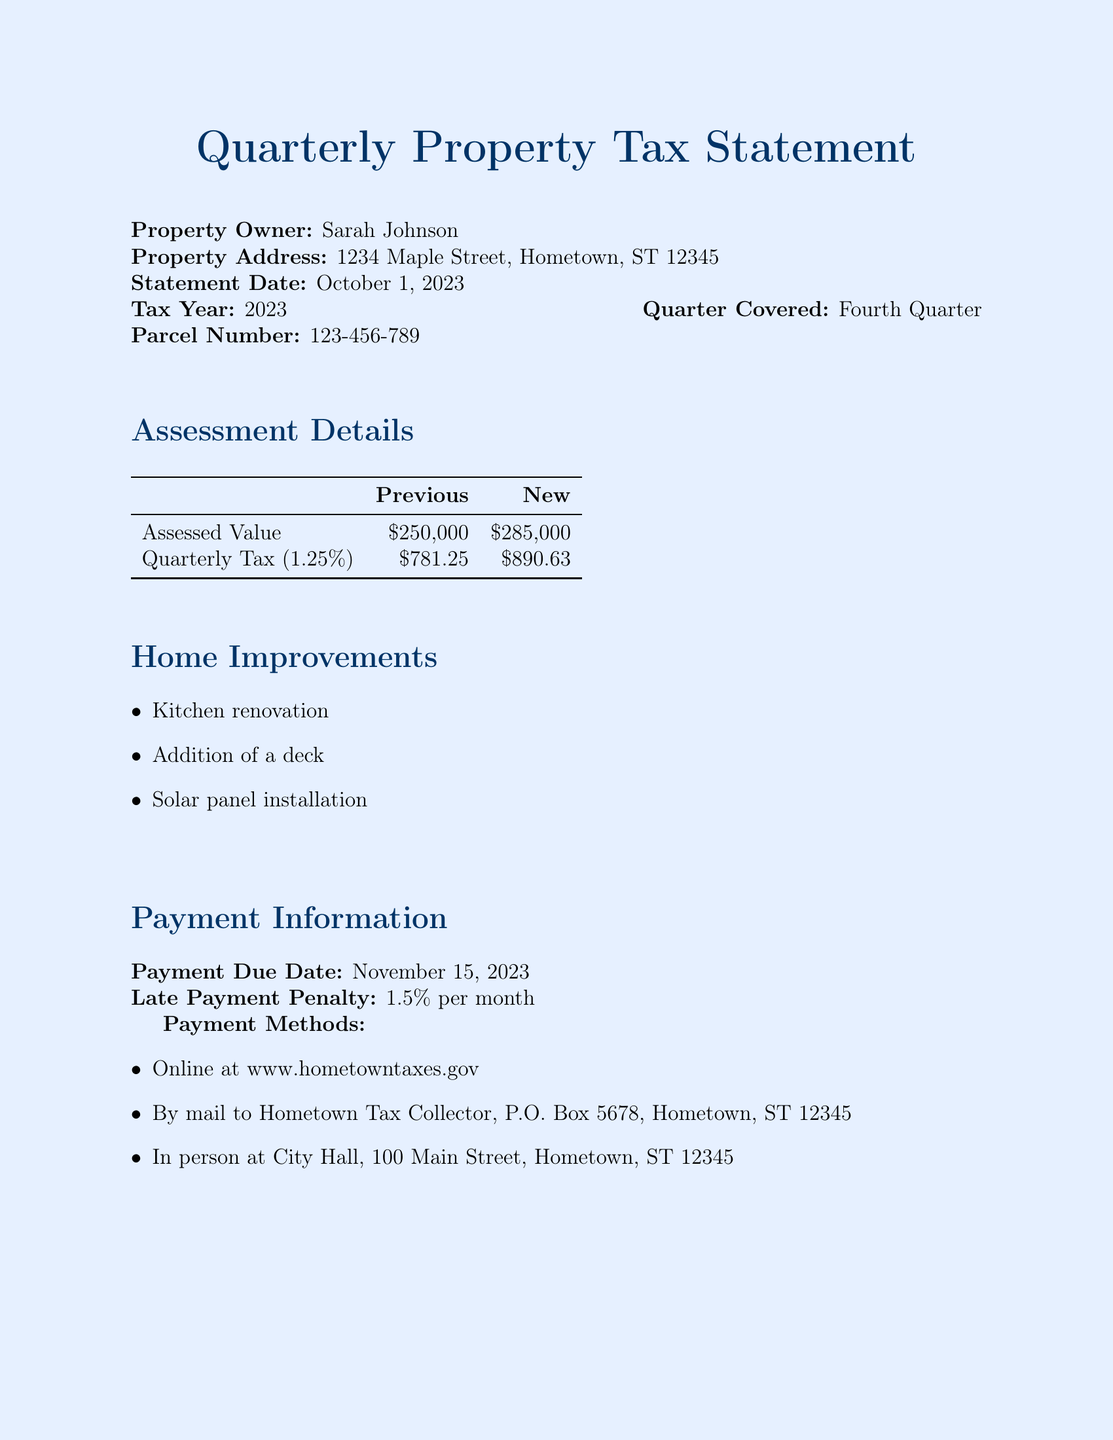What is the assessed value of the property? The assessed value is listed in the document under Assessment Details, where it states the previous and new values.
Answer: $285,000 When is the payment due date? The payment due date can be found in the Payment Information section of the document.
Answer: November 15, 2023 What is the late payment penalty? The late payment penalty is noted in the Payment Information section, which states the percentage applied to late payments.
Answer: 1.5% per month What home improvements were made? The document lists home improvements under the Home Improvements section and mentions three specific upgrades.
Answer: Kitchen renovation, Addition of a deck, Solar panel installation What is the quarterly tax rate? The quarterly tax is calculated based on the assessed value, and the tax rate is mentioned in the Assessment Details section.
Answer: 1.25% Who is the assessor contact? The assessor contact information is provided in the Additional Information section of the document, including the name and contact details.
Answer: John Smith What is the appeal deadline? The appeal deadline is listed in the Additional Information section of the document, indicating the last date for appeals.
Answer: November 30, 2023 What is the previous quarterly tax amount? The previous quarterly tax amount is provided in the Assessment Details section and is referenced by its numeric value.
Answer: $781.25 Where can payments be made? The document outlines payment methods in the Payment Information section, listing specific options for payments.
Answer: Online, By mail, In person 